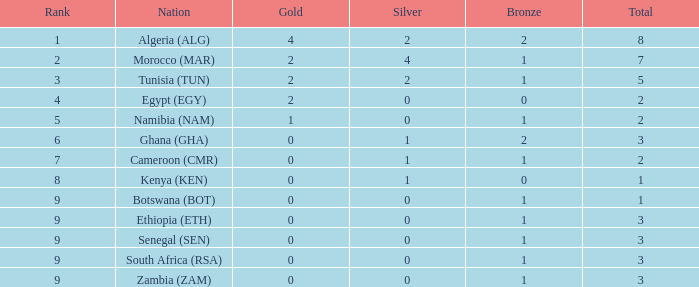What is the quantity of silver with a total below 1? 0.0. 